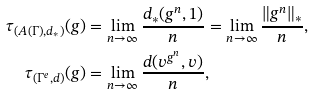Convert formula to latex. <formula><loc_0><loc_0><loc_500><loc_500>\tau _ { ( A ( \Gamma ) , d _ { * } ) } ( g ) & = \lim _ { n \to \infty } \frac { d _ { * } ( g ^ { n } , 1 ) } n = \lim _ { n \to \infty } \frac { \| g ^ { n } \| _ { * } } n , \\ \tau _ { ( \Gamma ^ { e } , d ) } ( g ) & = \lim _ { n \to \infty } \frac { d ( v ^ { g ^ { n } } , v ) } n ,</formula> 